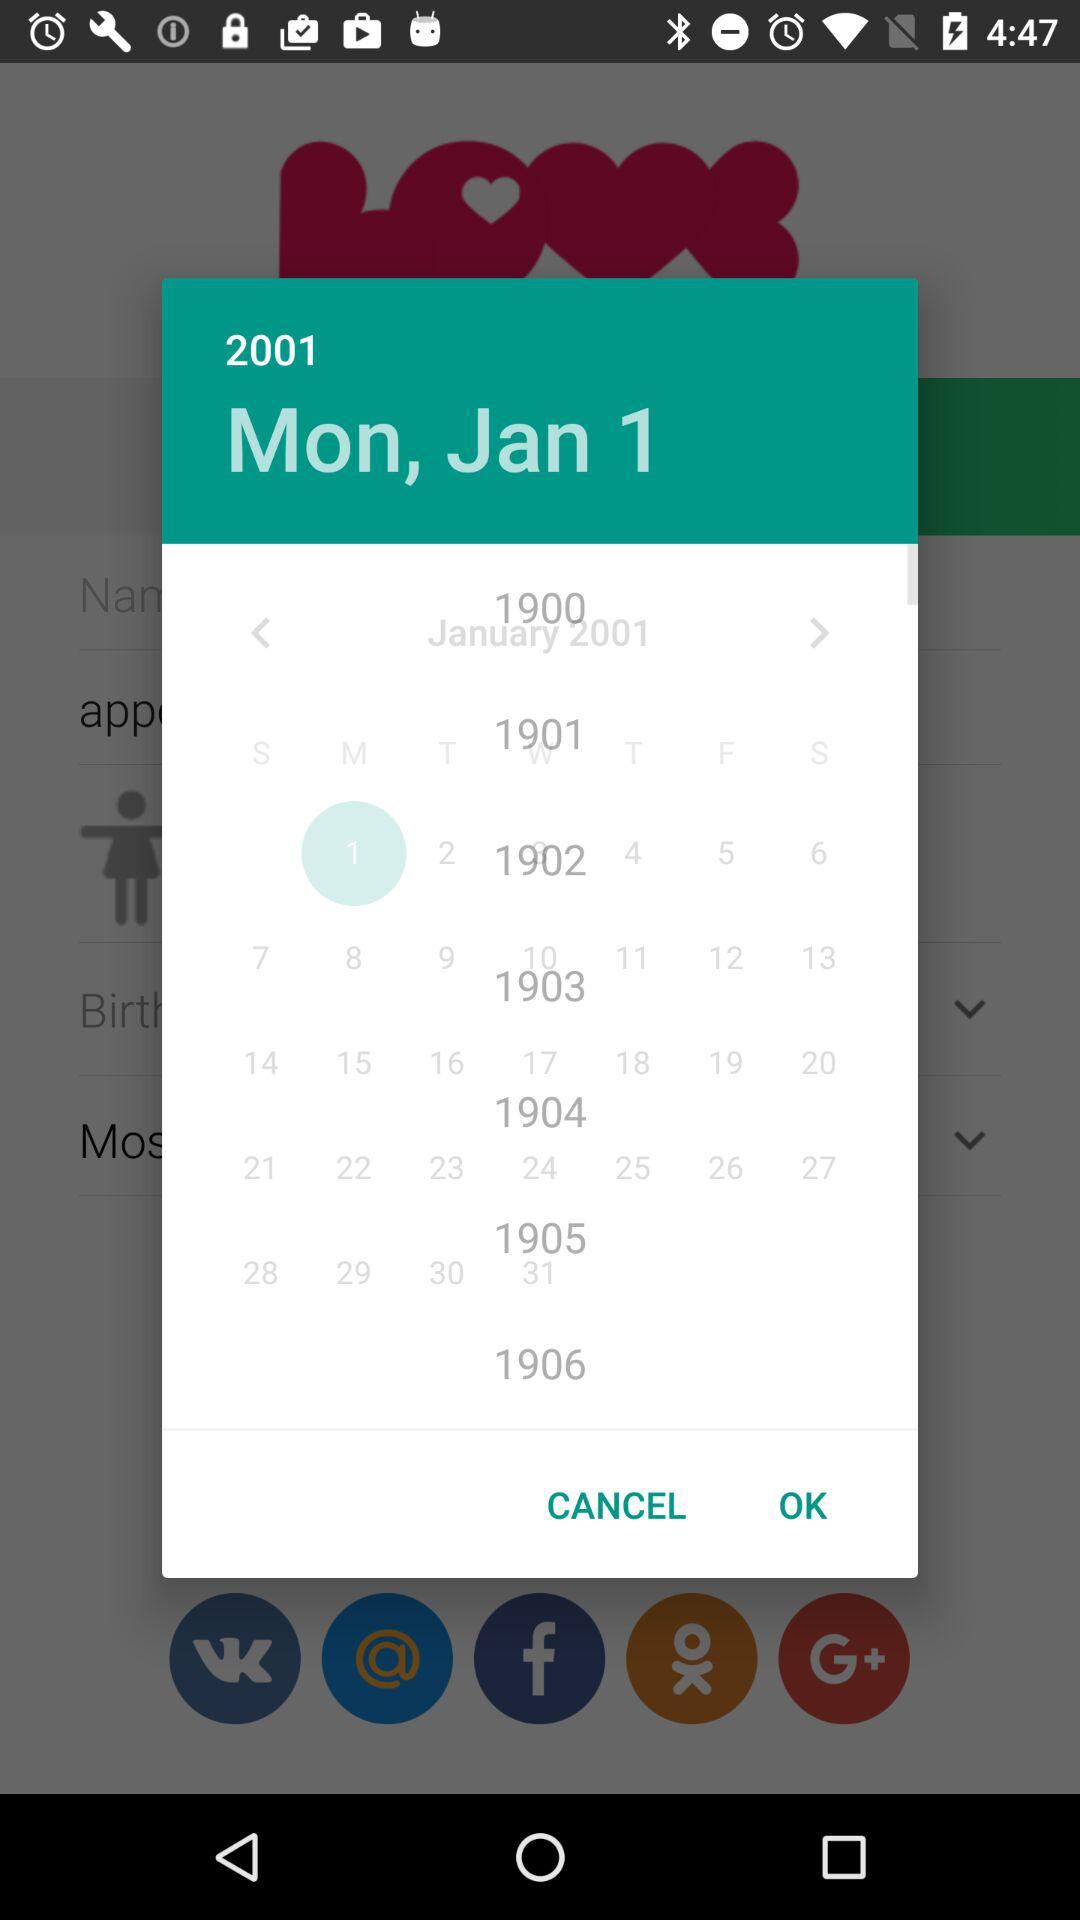Which date has been selected? The selected date is Monday, January 1, 2001. 